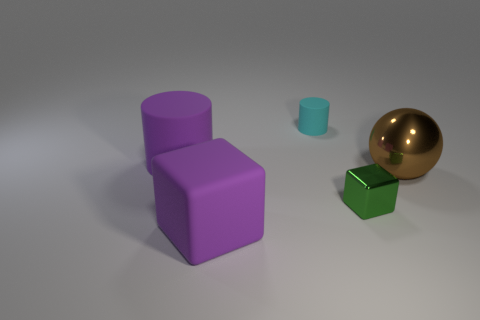Add 3 big matte blocks. How many objects exist? 8 Subtract all balls. How many objects are left? 4 Subtract 1 cyan cylinders. How many objects are left? 4 Subtract all tiny cyan metal objects. Subtract all green cubes. How many objects are left? 4 Add 1 big spheres. How many big spheres are left? 2 Add 2 small purple matte cubes. How many small purple matte cubes exist? 2 